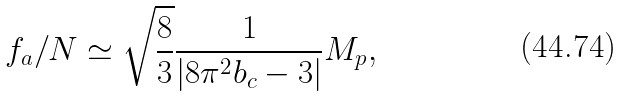<formula> <loc_0><loc_0><loc_500><loc_500>f _ { a } / N \simeq \sqrt { \frac { 8 } { 3 } } \frac { 1 } { | 8 \pi ^ { 2 } b _ { c } - 3 | } M _ { p } ,</formula> 